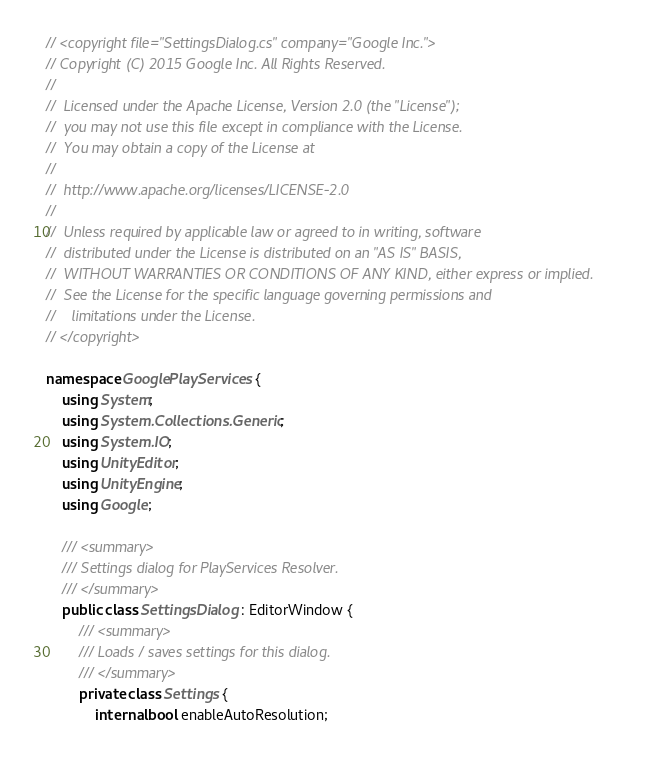Convert code to text. <code><loc_0><loc_0><loc_500><loc_500><_C#_>// <copyright file="SettingsDialog.cs" company="Google Inc.">
// Copyright (C) 2015 Google Inc. All Rights Reserved.
//
//  Licensed under the Apache License, Version 2.0 (the "License");
//  you may not use this file except in compliance with the License.
//  You may obtain a copy of the License at
//
//  http://www.apache.org/licenses/LICENSE-2.0
//
//  Unless required by applicable law or agreed to in writing, software
//  distributed under the License is distributed on an "AS IS" BASIS,
//  WITHOUT WARRANTIES OR CONDITIONS OF ANY KIND, either express or implied.
//  See the License for the specific language governing permissions and
//    limitations under the License.
// </copyright>

namespace GooglePlayServices {
    using System;
    using System.Collections.Generic;
    using System.IO;
    using UnityEditor;
    using UnityEngine;
    using Google;

    /// <summary>
    /// Settings dialog for PlayServices Resolver.
    /// </summary>
    public class SettingsDialog : EditorWindow {
        /// <summary>
        /// Loads / saves settings for this dialog.
        /// </summary>
        private class Settings {
            internal bool enableAutoResolution;</code> 